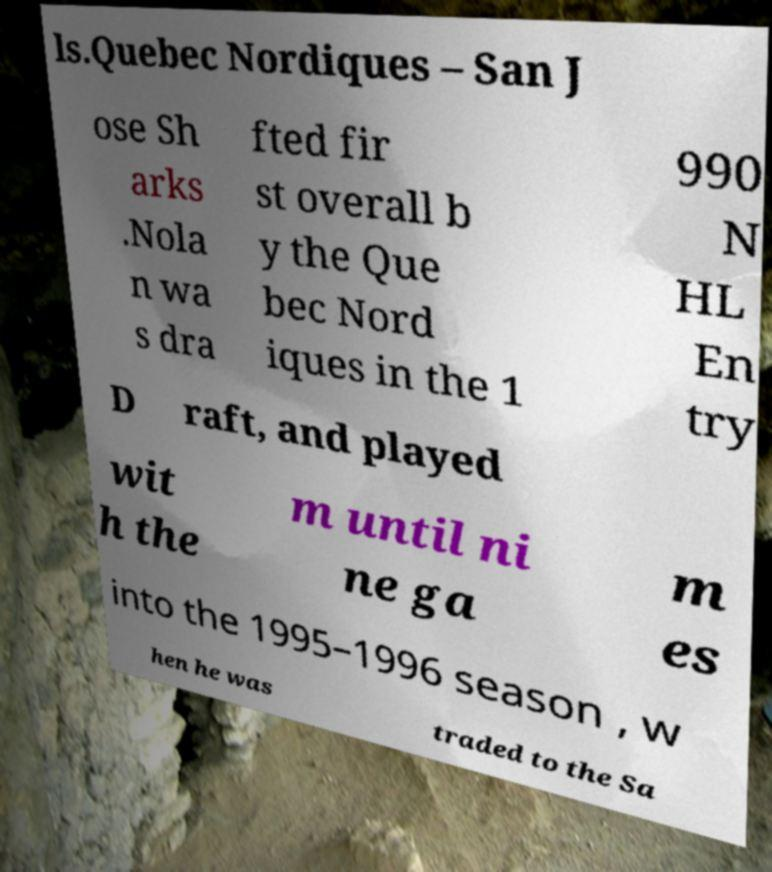Could you extract and type out the text from this image? ls.Quebec Nordiques – San J ose Sh arks .Nola n wa s dra fted fir st overall b y the Que bec Nord iques in the 1 990 N HL En try D raft, and played wit h the m until ni ne ga m es into the 1995–1996 season , w hen he was traded to the Sa 